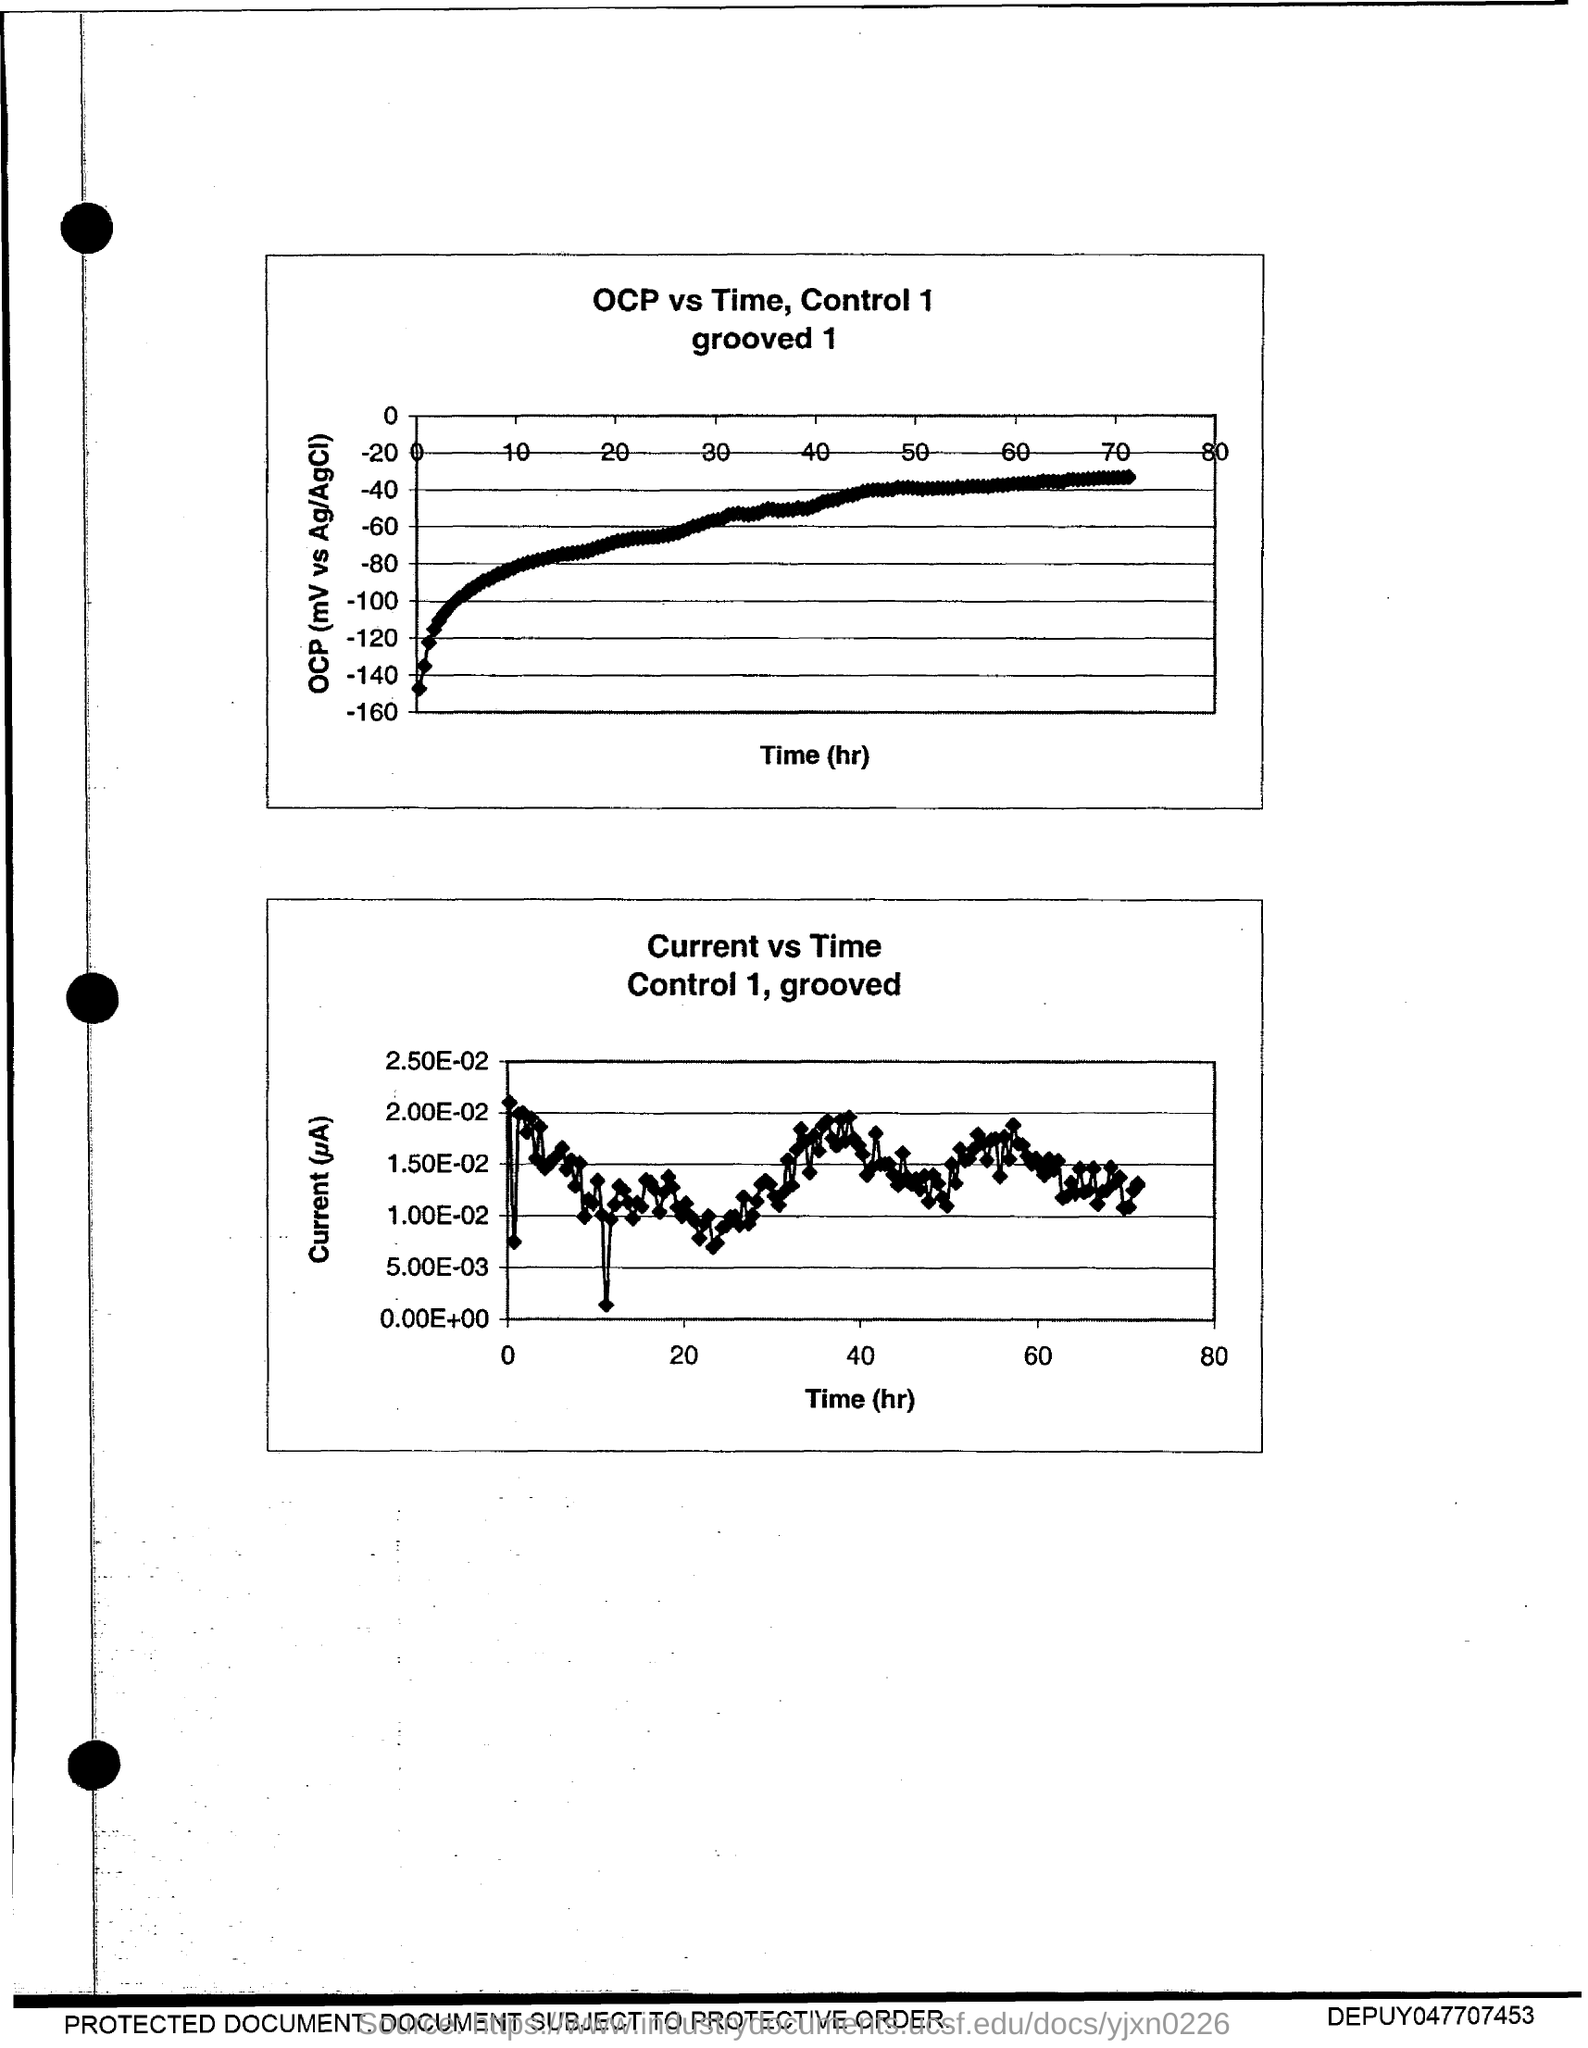What is the title of the first graph?
Ensure brevity in your answer.  OCP vs Time, Control 1. 